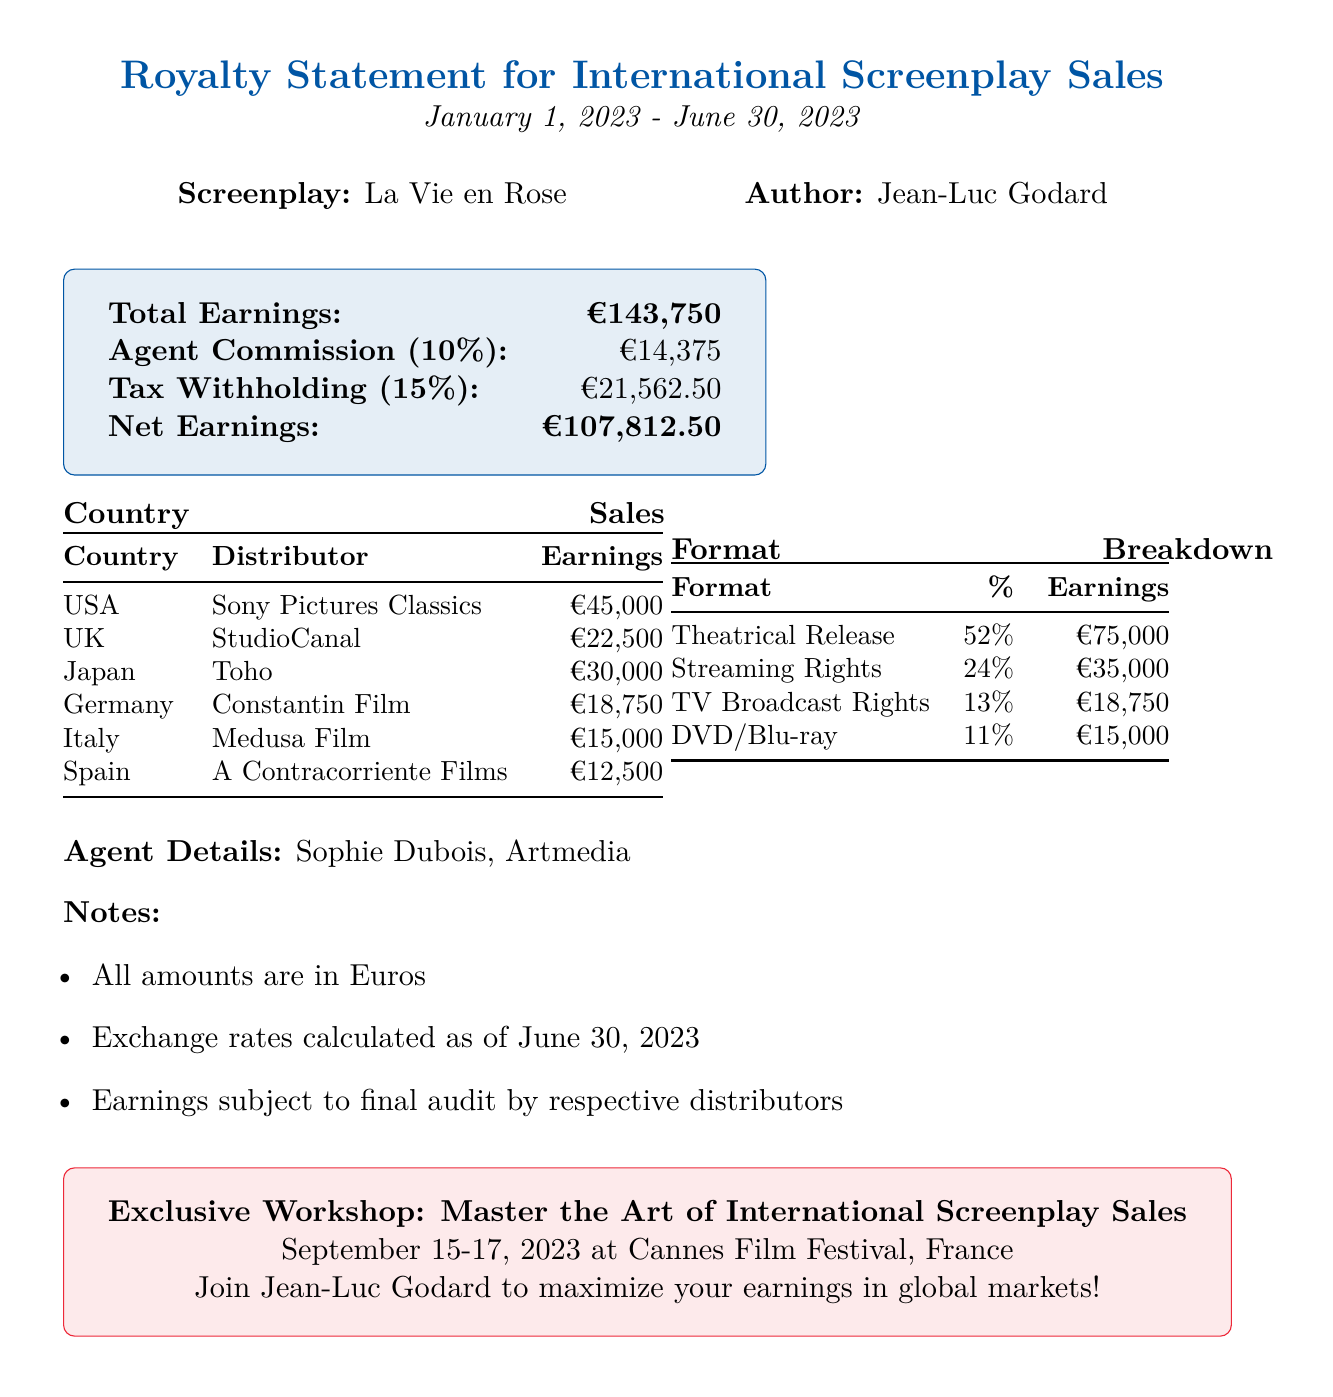What is the document title? The document title is located at the top of the document.
Answer: Royalty Statement for International Screenplay Sales Who is the author of the screenplay? The author is mentioned alongside the screenplay title.
Answer: Jean-Luc Godard What is the total earnings reported? Total earnings are prominently displayed in a section of the document.
Answer: €143,750 Which country had the highest earnings? The country with the highest earnings is listed in the country sales table.
Answer: United States What is the commission amount for the agent? The commission amount is found in the agent details section.
Answer: €14,375 What percentage of earnings comes from Theatrical Release format? The format breakdown section provides the percentage for each format.
Answer: 52% What is the net earnings after tax? Net earnings are calculated after deducting taxes from total earnings, presented in the document.
Answer: €107,812.50 When will the workshop take place? The workshop date is included in the promotional section of the document.
Answer: September 15-17, 2023 Which distributor is associated with Japan? The distributor for Japan is specified in the country sales list.
Answer: Toho 